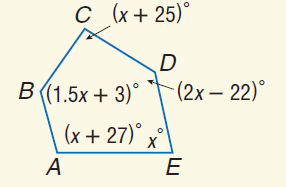Answer the mathemtical geometry problem and directly provide the correct option letter.
Question: Find m \angle C.
Choices: A: 78 B: 103 C: 105 D: 120 B 